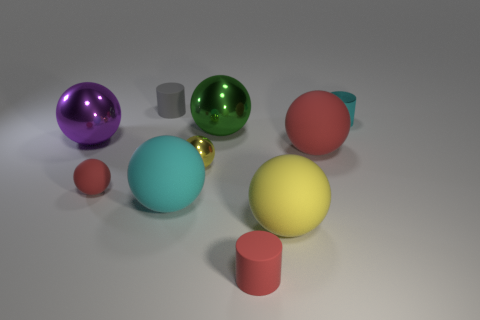Subtract 4 balls. How many balls are left? 3 Subtract all cyan spheres. How many spheres are left? 6 Subtract all small rubber spheres. How many spheres are left? 6 Subtract all gray spheres. Subtract all purple cylinders. How many spheres are left? 7 Subtract all cylinders. How many objects are left? 7 Add 3 brown shiny things. How many brown shiny things exist? 3 Subtract 1 cyan cylinders. How many objects are left? 9 Subtract all metallic spheres. Subtract all tiny metallic cylinders. How many objects are left? 6 Add 8 gray cylinders. How many gray cylinders are left? 9 